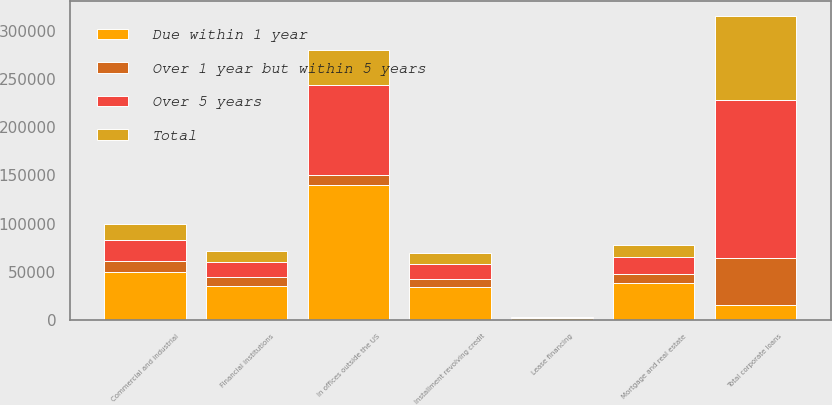<chart> <loc_0><loc_0><loc_500><loc_500><stacked_bar_chart><ecel><fcel>Commercial and industrial<fcel>Financial institutions<fcel>Mortgage and real estate<fcel>Installment revolving credit<fcel>Lease financing<fcel>In offices outside the US<fcel>Total corporate loans<nl><fcel>Over 5 years<fcel>21851<fcel>15652<fcel>17051<fcel>15203<fcel>669<fcel>93993<fcel>164419<nl><fcel>Total<fcel>15799<fcel>11316<fcel>12327<fcel>10993<fcel>484<fcel>35808<fcel>86727<nl><fcel>Over 1 year but within 5 years<fcel>11936<fcel>8549<fcel>9313<fcel>8305<fcel>365<fcel>10093<fcel>48561<nl><fcel>Due within 1 year<fcel>49586<fcel>35517<fcel>38691<fcel>34501<fcel>1518<fcel>139894<fcel>15652<nl></chart> 